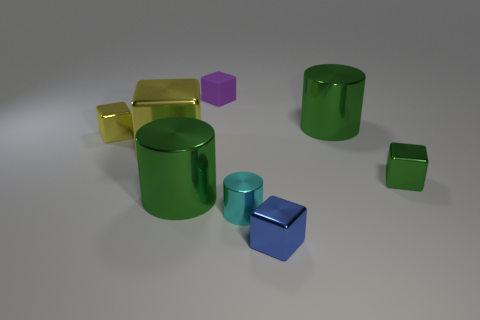Is there anything else that is made of the same material as the small cylinder?
Offer a terse response. Yes. The blue metallic thing that is the same shape as the purple rubber object is what size?
Ensure brevity in your answer.  Small. Are there more shiny things in front of the big yellow metal cube than blue balls?
Your answer should be very brief. Yes. Do the green block that is to the right of the purple rubber object and the purple cube have the same material?
Ensure brevity in your answer.  No. There is a cyan metal cylinder in front of the small purple block on the right side of the yellow cube that is behind the large yellow object; what size is it?
Your answer should be compact. Small. There is a cyan thing that is made of the same material as the blue cube; what is its size?
Offer a terse response. Small. What is the color of the big metallic object that is left of the tiny blue metallic cube and behind the green block?
Your answer should be compact. Yellow. Do the green metal thing left of the small cyan thing and the big green metal object that is to the right of the small matte cube have the same shape?
Give a very brief answer. Yes. There is a big object right of the tiny rubber thing; what material is it?
Offer a terse response. Metal. What is the size of the other shiny cube that is the same color as the large metal block?
Ensure brevity in your answer.  Small. 